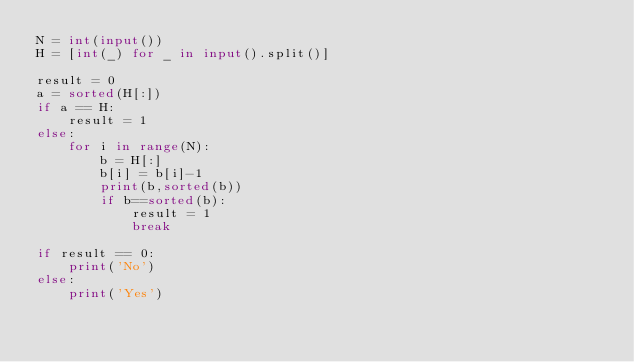<code> <loc_0><loc_0><loc_500><loc_500><_Python_>N = int(input())
H = [int(_) for _ in input().split()]

result = 0
a = sorted(H[:])
if a == H:
    result = 1
else:
    for i in range(N):
        b = H[:]
        b[i] = b[i]-1
        print(b,sorted(b))
        if b==sorted(b):
            result = 1
            break

if result == 0:
    print('No')
else:
    print('Yes')</code> 